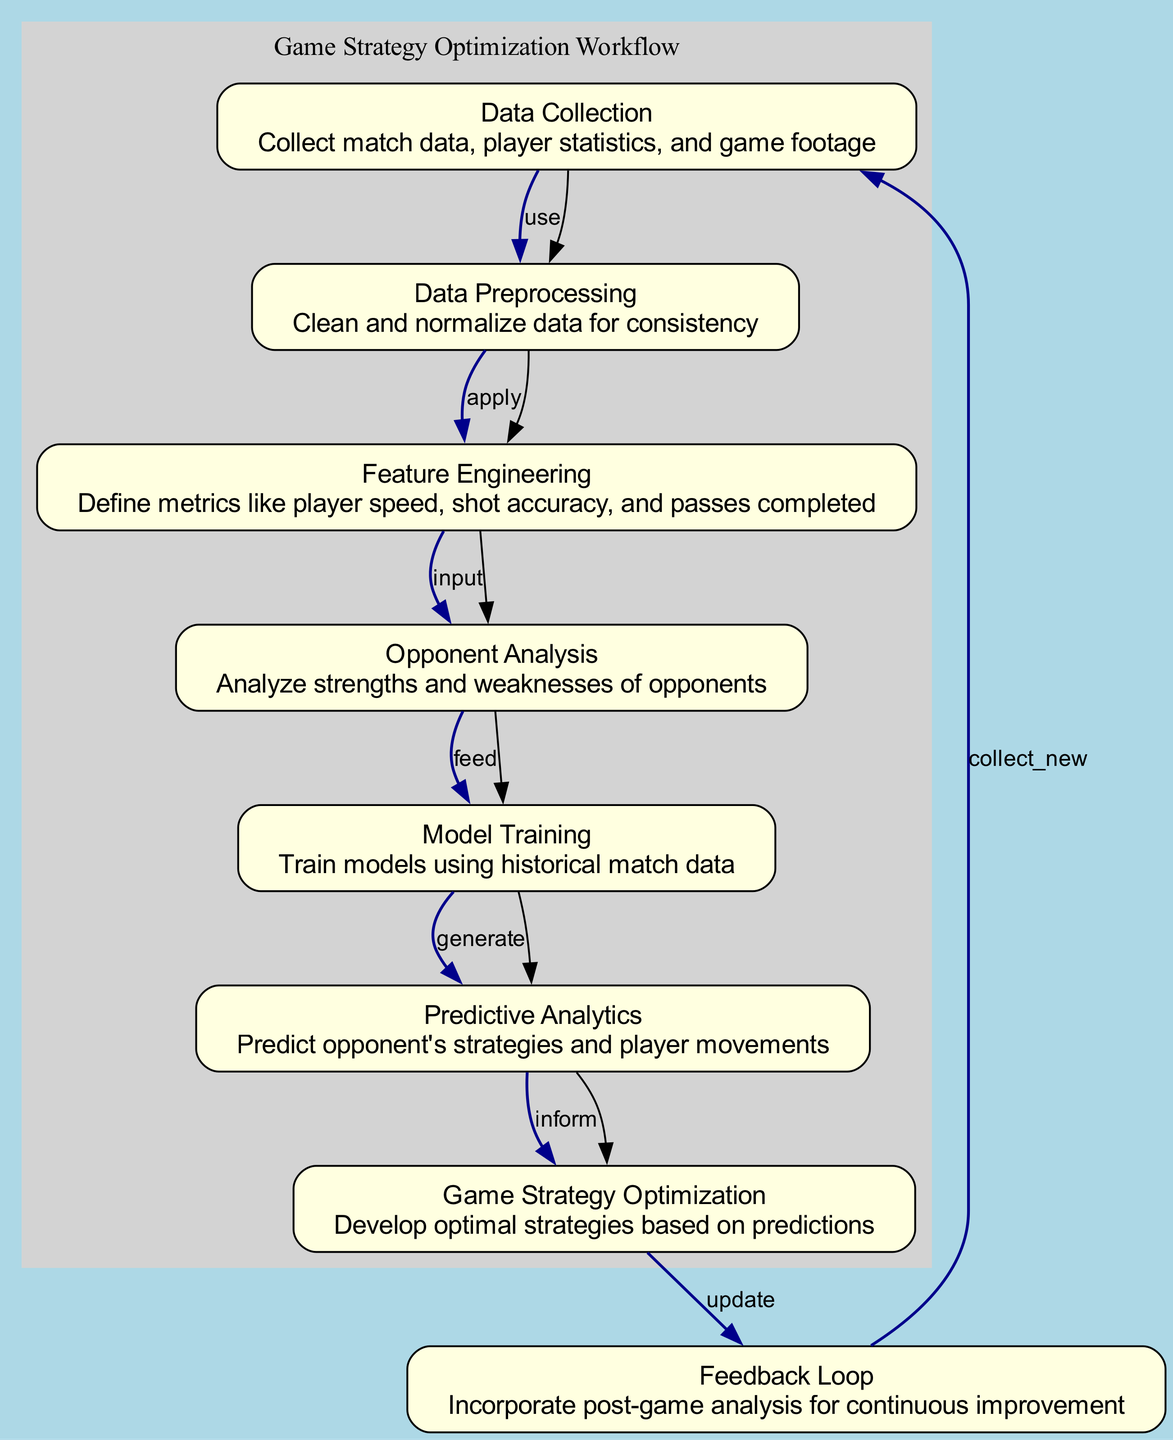What is the first step in the process? The first node in the diagram is "Data Collection" which indicates it is the starting point. It's indicated as the node with ID "1".
Answer: Data Collection How many nodes are there in the diagram? By counting the individual nodes listed under "nodes", we find a total of eight nodes.
Answer: 8 What is the relationship between "Opponent Analysis" and "Model Training"? The edge connecting "Opponent Analysis" (node 4) and "Model Training" (node 5) indicates that "Opponent Analysis" feeds into "Model Training".
Answer: feed Which node describes the analysis of strengths and weaknesses of opponents? The label for node 4 in the diagram specifically mentions "Analyze strengths and weaknesses of opponents".
Answer: Opponent Analysis What process follows "Predictive Analytics"? The edge from "Predictive Analytics" (node 6) to "Game Strategy Optimization" (node 7) indicates that "Predictive Analytics" informs the "Game Strategy Optimization".
Answer: Game Strategy Optimization How does "Game Strategy Optimization" update the process? The edge from "Game Strategy Optimization" (node 7) to "Feedback Loop" (node 8) shows that it updates the feedback for continuous improvement.
Answer: update What is the main purpose of "Feature Engineering"? Node 3 describes Feature Engineering, which defines metrics like player speed, shot accuracy, and passes completed, indicating its purpose.
Answer: Define metrics What type of data is cleaned and normalized during the second step? The node for "Data Preprocessing" explains that it involves cleaning and normalizing data, which implies that the data being processed must be consistent.
Answer: Data for consistency What role does the "Feedback Loop" play in the process? The "Feedback Loop" connects back to "Data Collection", indicating that it gathers new data after analyzing outcomes to enhance future strategy optimization.
Answer: continuous improvement 